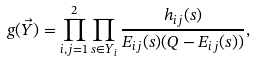Convert formula to latex. <formula><loc_0><loc_0><loc_500><loc_500>g ( \vec { Y } ) = \prod _ { i , j = 1 } ^ { 2 } \prod _ { s \in Y _ { i } } \frac { h _ { i j } ( s ) } { E _ { i j } ( s ) ( Q - E _ { i j } ( s ) ) } ,</formula> 